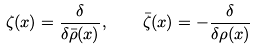<formula> <loc_0><loc_0><loc_500><loc_500>\zeta ( { x } ) = \frac { \delta } { \delta \bar { \rho } ( { x } ) } , \quad \bar { \zeta } ( { x } ) = - \frac { \delta } { \delta \rho ( { x } ) }</formula> 